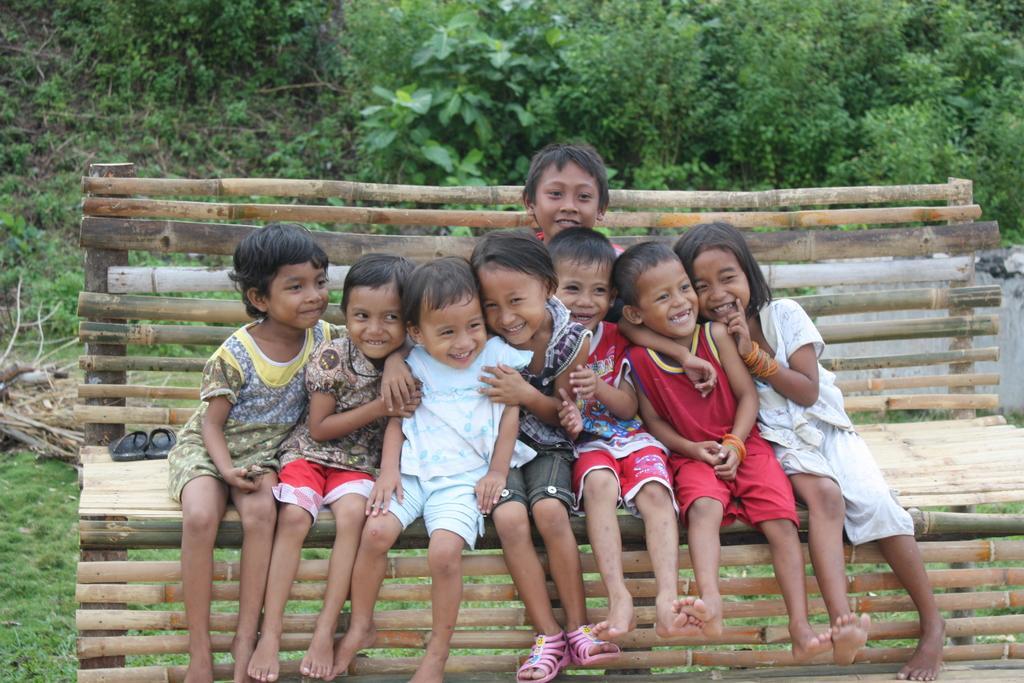How would you summarize this image in a sentence or two? In this image few kids are sitting on the bench and are smiling. The kid at the middle is wearing slippers. Left side of the bench there are slippers. Background of the image is having plants. Left side bottom of image is grassy land. 